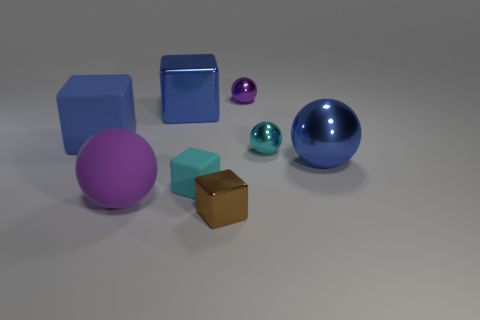Which objects have a reflective surface? The objects with reflective surfaces in the image are the large blue rubber sphere and the two smaller cyan spheres. These objects have a noticeable shine to them, indicating their reflective quality.  Are there any objects casting noticeable shadows? Yes, all objects in the image are casting shadows. The light source appears to be coming from the top left, resulting in shadows extending toward the bottom right of each object. 